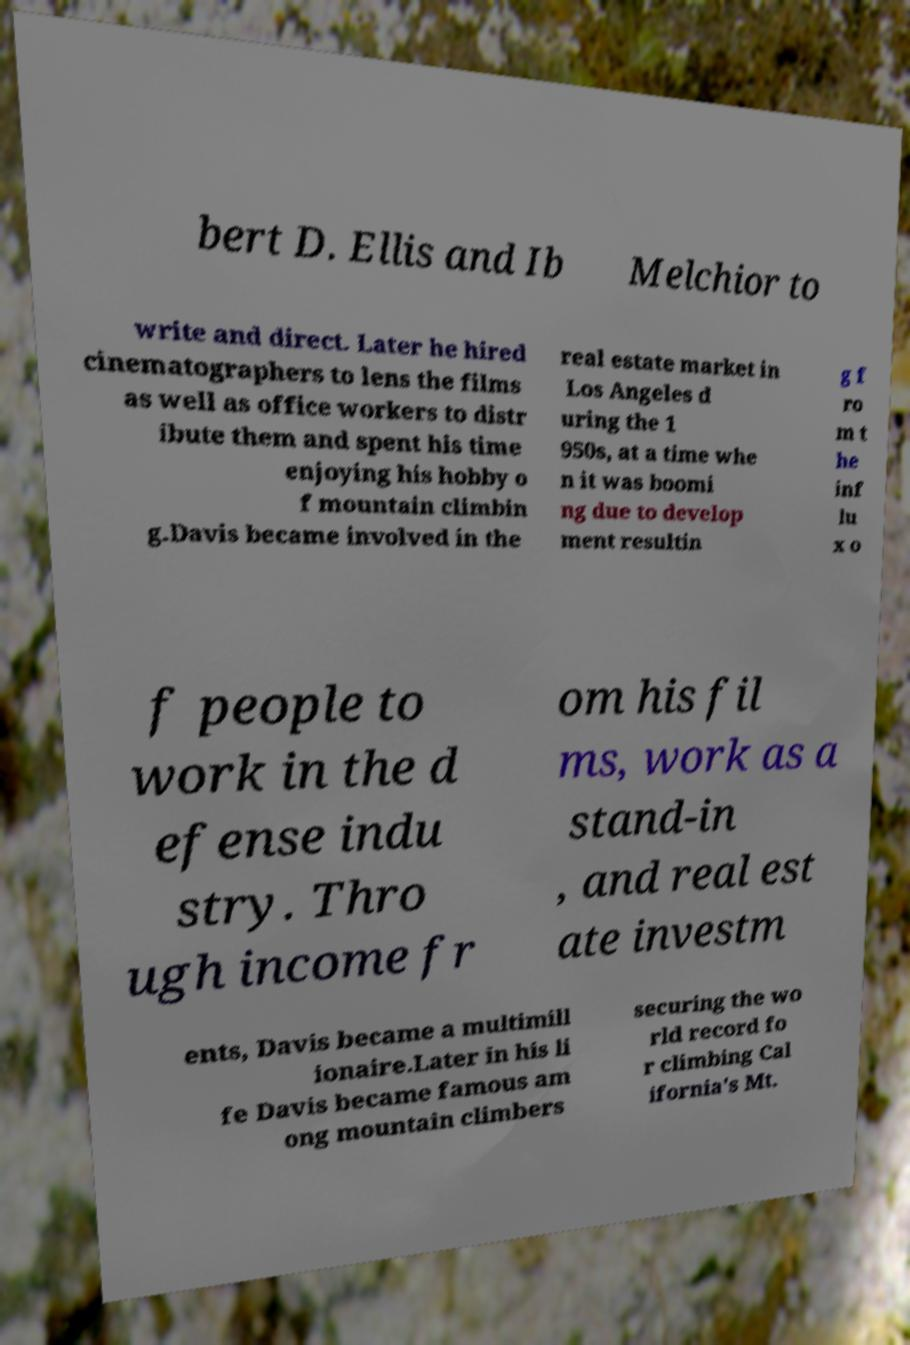Please read and relay the text visible in this image. What does it say? bert D. Ellis and Ib Melchior to write and direct. Later he hired cinematographers to lens the films as well as office workers to distr ibute them and spent his time enjoying his hobby o f mountain climbin g.Davis became involved in the real estate market in Los Angeles d uring the 1 950s, at a time whe n it was boomi ng due to develop ment resultin g f ro m t he inf lu x o f people to work in the d efense indu stry. Thro ugh income fr om his fil ms, work as a stand-in , and real est ate investm ents, Davis became a multimill ionaire.Later in his li fe Davis became famous am ong mountain climbers securing the wo rld record fo r climbing Cal ifornia's Mt. 